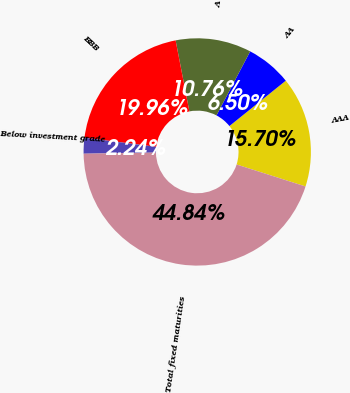<chart> <loc_0><loc_0><loc_500><loc_500><pie_chart><fcel>AAA<fcel>AA<fcel>A<fcel>BBB<fcel>Below investment grade<fcel>Total fixed maturities<nl><fcel>15.7%<fcel>6.5%<fcel>10.76%<fcel>19.96%<fcel>2.24%<fcel>44.84%<nl></chart> 